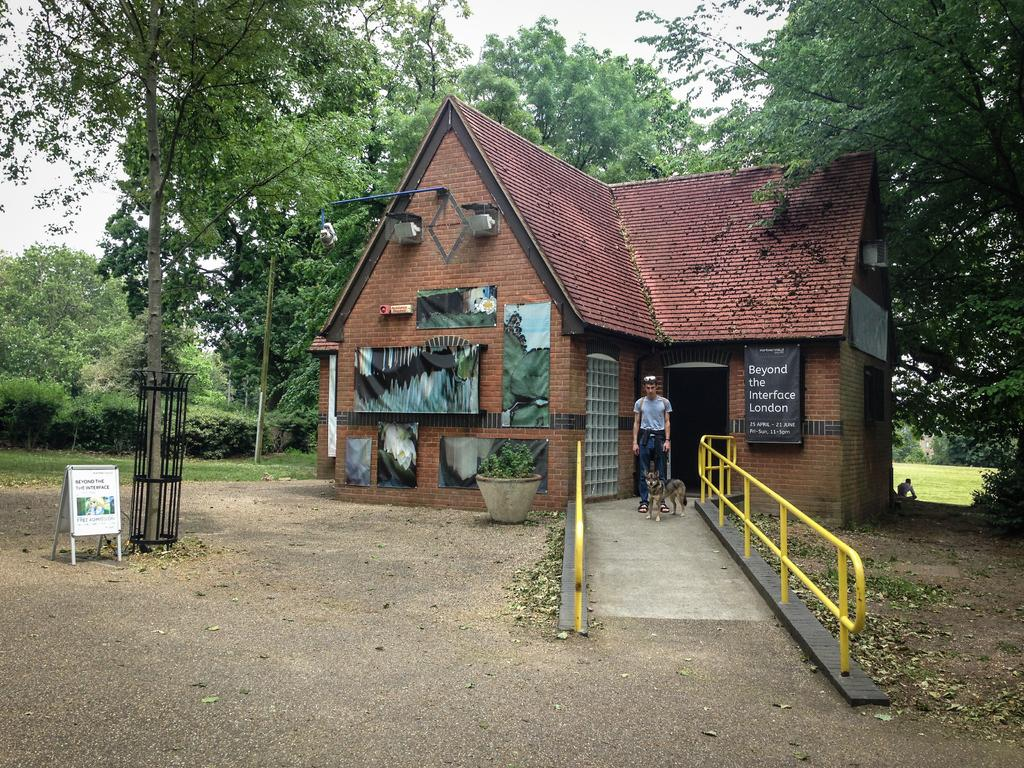<image>
Summarize the visual content of the image. A brick building is shown with a banner hanging on the front for Beyond the Interface London. 